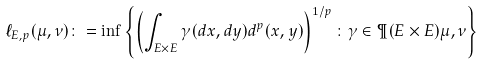<formula> <loc_0><loc_0><loc_500><loc_500>\ell _ { E , p } ( \mu , \nu ) \colon = \inf \left \{ \left ( \int _ { E \times E } \gamma ( d x , d y ) d ^ { p } ( x , y ) \right ) ^ { 1 / p } \colon \gamma \in \P ( E \times E ) \mu , \nu \right \}</formula> 